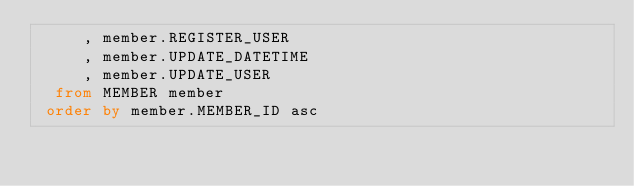<code> <loc_0><loc_0><loc_500><loc_500><_SQL_>     , member.REGISTER_USER
     , member.UPDATE_DATETIME
     , member.UPDATE_USER
  from MEMBER member
 order by member.MEMBER_ID asc
</code> 